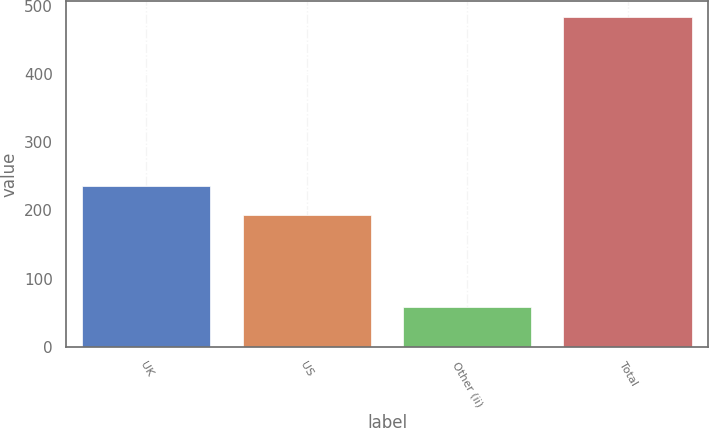<chart> <loc_0><loc_0><loc_500><loc_500><bar_chart><fcel>UK<fcel>US<fcel>Other (ii)<fcel>Total<nl><fcel>235.5<fcel>193<fcel>58<fcel>483<nl></chart> 